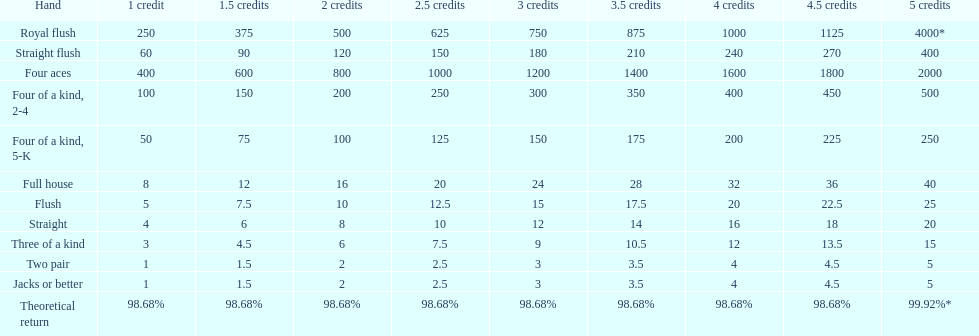What is the total amount of a 3 credit straight flush? 180. 